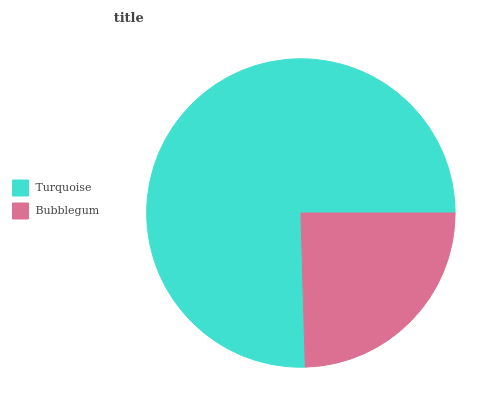Is Bubblegum the minimum?
Answer yes or no. Yes. Is Turquoise the maximum?
Answer yes or no. Yes. Is Bubblegum the maximum?
Answer yes or no. No. Is Turquoise greater than Bubblegum?
Answer yes or no. Yes. Is Bubblegum less than Turquoise?
Answer yes or no. Yes. Is Bubblegum greater than Turquoise?
Answer yes or no. No. Is Turquoise less than Bubblegum?
Answer yes or no. No. Is Turquoise the high median?
Answer yes or no. Yes. Is Bubblegum the low median?
Answer yes or no. Yes. Is Bubblegum the high median?
Answer yes or no. No. Is Turquoise the low median?
Answer yes or no. No. 